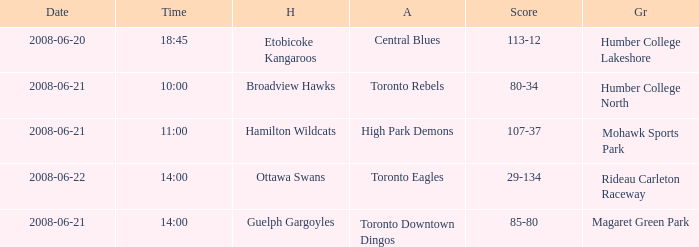What is the Away with a Ground that is humber college north? Toronto Rebels. 